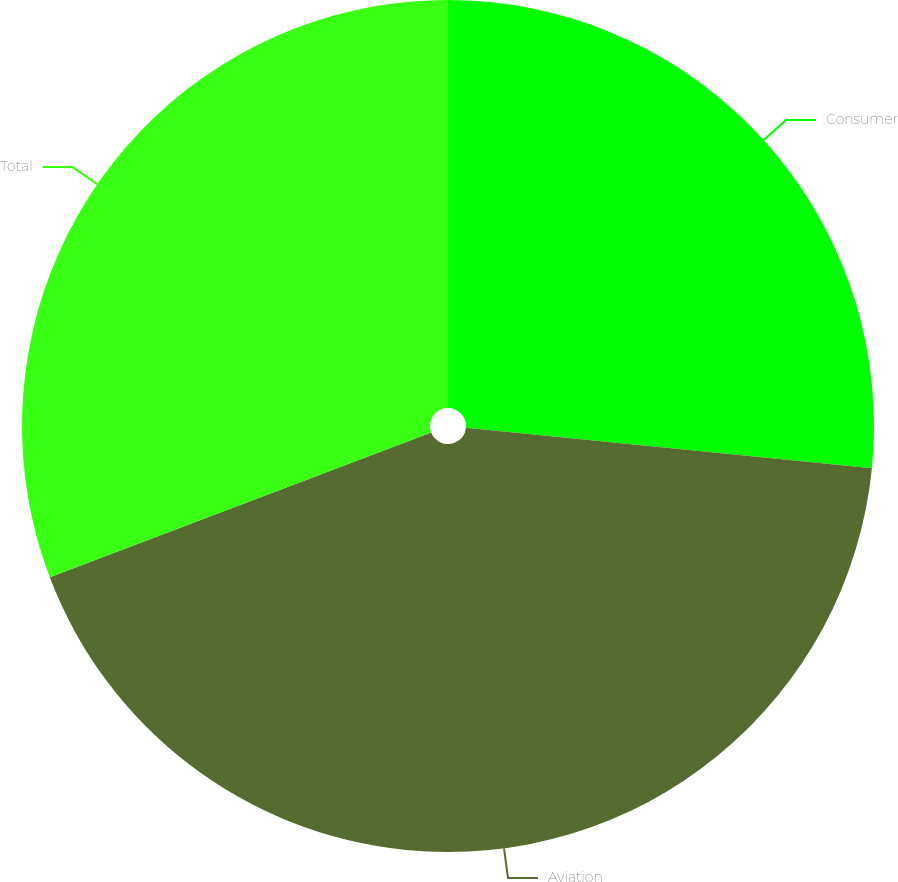<chart> <loc_0><loc_0><loc_500><loc_500><pie_chart><fcel>Consumer<fcel>Aviation<fcel>Total<nl><fcel>26.58%<fcel>42.64%<fcel>30.78%<nl></chart> 